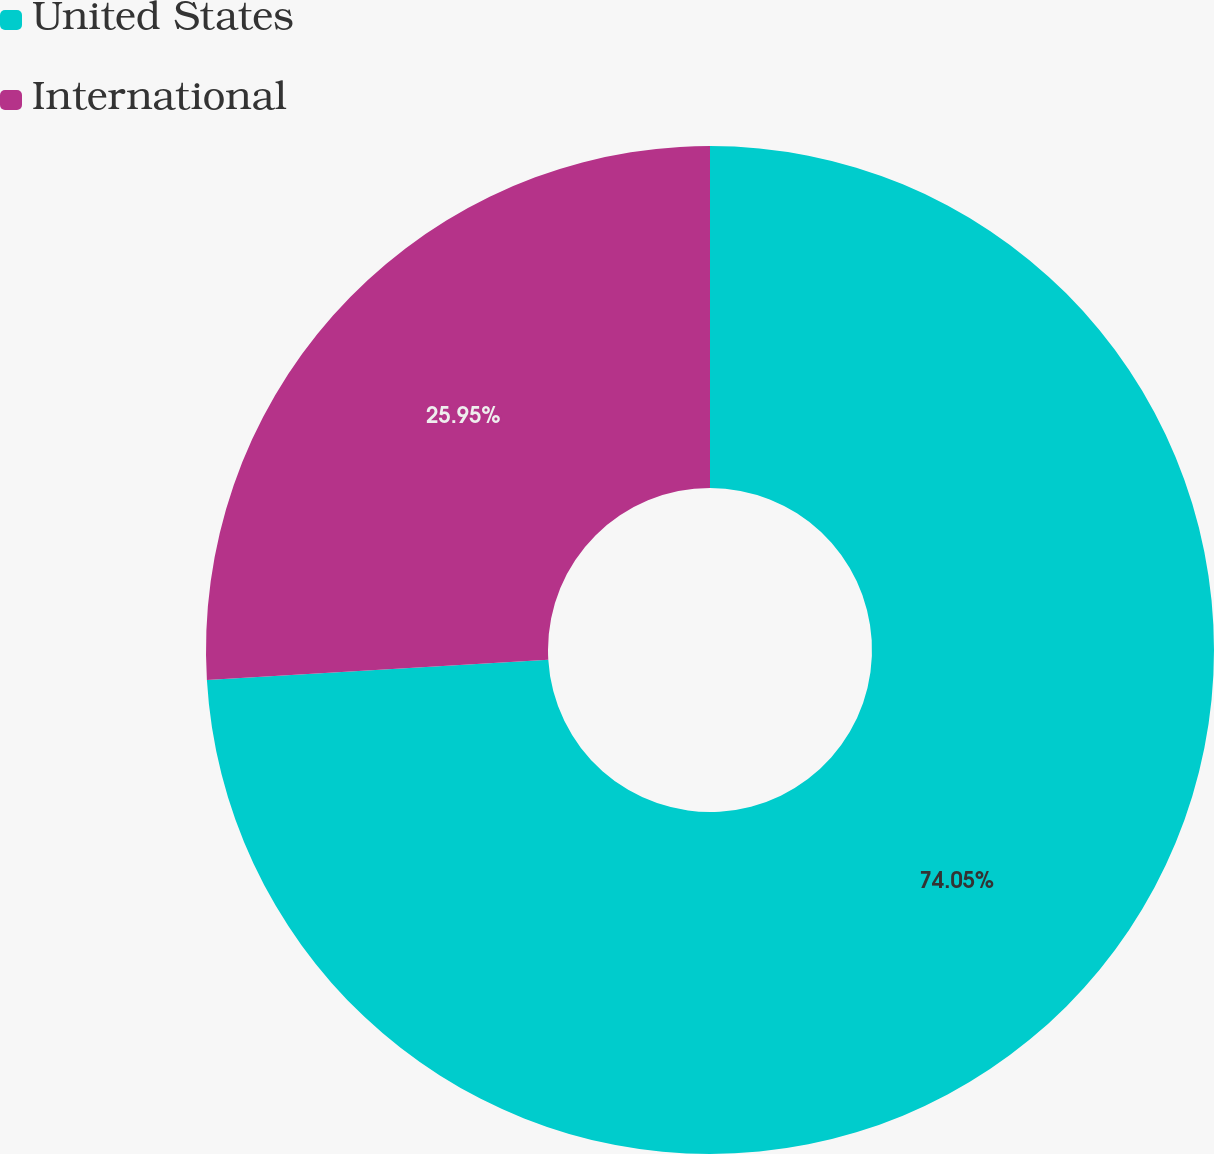<chart> <loc_0><loc_0><loc_500><loc_500><pie_chart><fcel>United States<fcel>International<nl><fcel>74.05%<fcel>25.95%<nl></chart> 